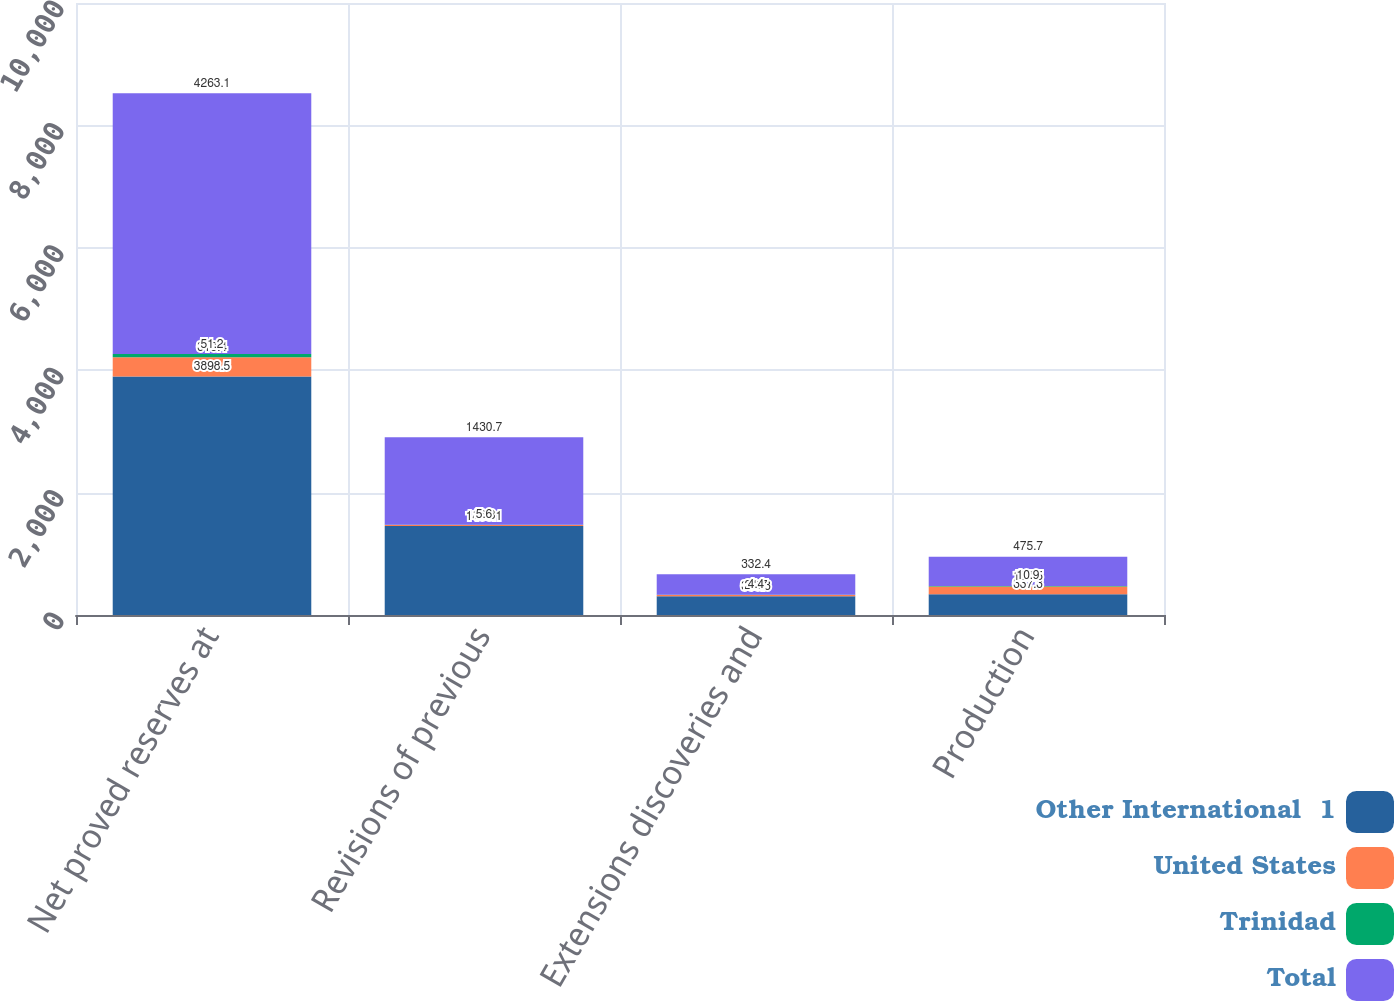Convert chart. <chart><loc_0><loc_0><loc_500><loc_500><stacked_bar_chart><ecel><fcel>Net proved reserves at<fcel>Revisions of previous<fcel>Extensions discoveries and<fcel>Production<nl><fcel>Other International  1<fcel>3898.5<fcel>1453.1<fcel>306.3<fcel>337.3<nl><fcel>United States<fcel>313.4<fcel>16.8<fcel>21.7<fcel>127.5<nl><fcel>Trinidad<fcel>51.2<fcel>5.6<fcel>4.4<fcel>10.9<nl><fcel>Total<fcel>4263.1<fcel>1430.7<fcel>332.4<fcel>475.7<nl></chart> 